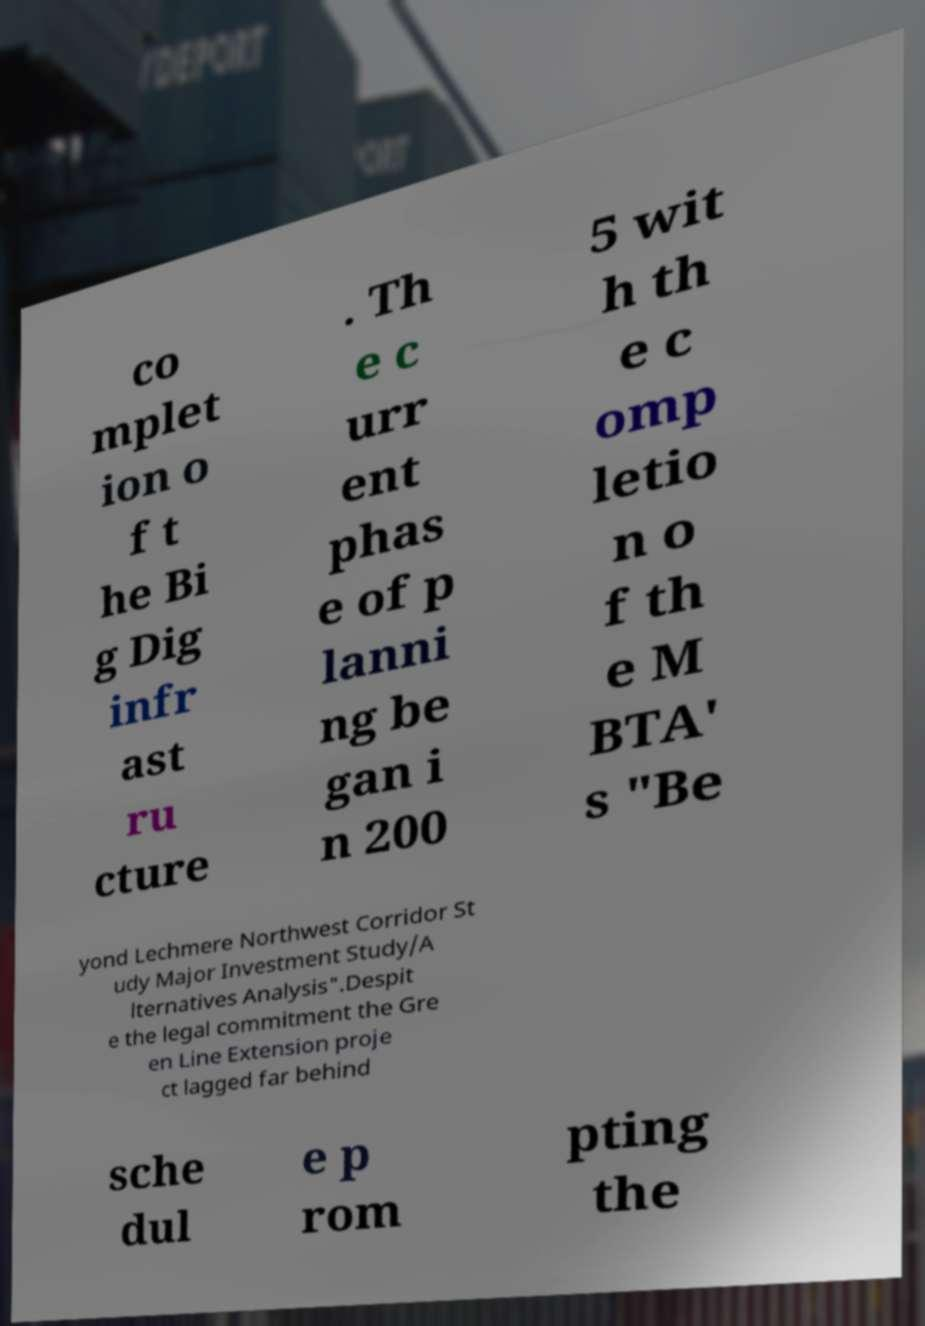I need the written content from this picture converted into text. Can you do that? co mplet ion o f t he Bi g Dig infr ast ru cture . Th e c urr ent phas e of p lanni ng be gan i n 200 5 wit h th e c omp letio n o f th e M BTA' s "Be yond Lechmere Northwest Corridor St udy Major Investment Study/A lternatives Analysis".Despit e the legal commitment the Gre en Line Extension proje ct lagged far behind sche dul e p rom pting the 